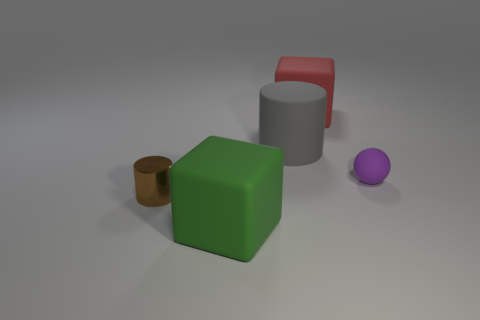Add 1 large yellow things. How many objects exist? 6 Subtract all gray balls. How many cyan cubes are left? 0 Subtract all gray cylinders. How many cylinders are left? 1 Subtract all cylinders. How many objects are left? 3 Subtract 1 spheres. How many spheres are left? 0 Subtract all cyan cylinders. Subtract all green balls. How many cylinders are left? 2 Subtract all green matte things. Subtract all balls. How many objects are left? 3 Add 2 rubber spheres. How many rubber spheres are left? 3 Add 1 large purple metallic cylinders. How many large purple metallic cylinders exist? 1 Subtract 0 cyan cubes. How many objects are left? 5 